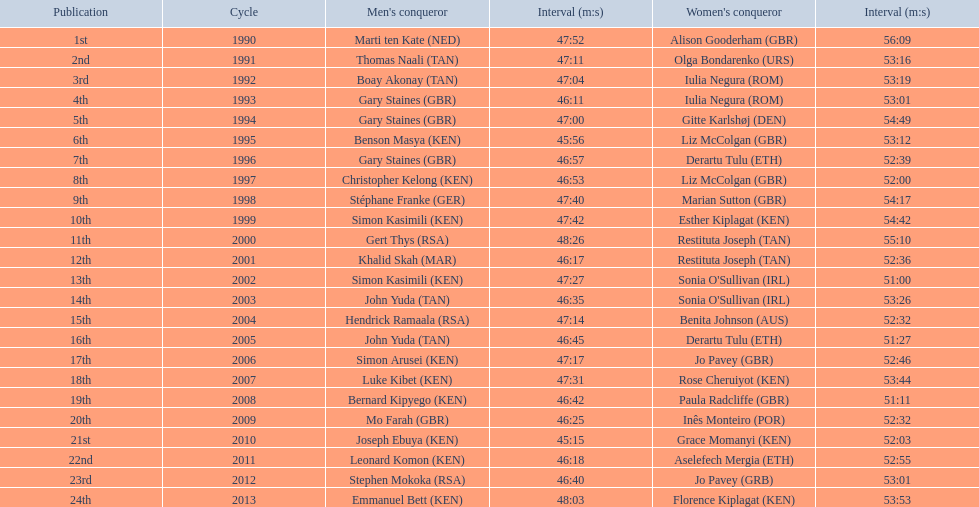Who were all the runners' times between 1990 and 2013? 47:52, 56:09, 47:11, 53:16, 47:04, 53:19, 46:11, 53:01, 47:00, 54:49, 45:56, 53:12, 46:57, 52:39, 46:53, 52:00, 47:40, 54:17, 47:42, 54:42, 48:26, 55:10, 46:17, 52:36, 47:27, 51:00, 46:35, 53:26, 47:14, 52:32, 46:45, 51:27, 47:17, 52:46, 47:31, 53:44, 46:42, 51:11, 46:25, 52:32, 45:15, 52:03, 46:18, 52:55, 46:40, 53:01, 48:03, 53:53. Which was the fastest time? 45:15. Who ran that time? Joseph Ebuya (KEN). 